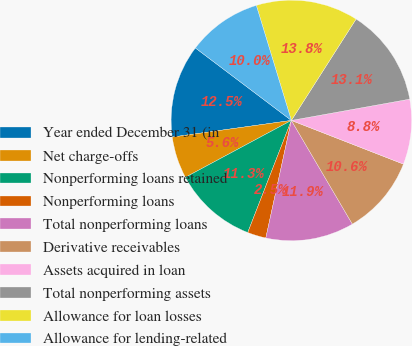Convert chart to OTSL. <chart><loc_0><loc_0><loc_500><loc_500><pie_chart><fcel>Year ended December 31 (in<fcel>Net charge-offs<fcel>Nonperforming loans retained<fcel>Nonperforming loans<fcel>Total nonperforming loans<fcel>Derivative receivables<fcel>Assets acquired in loan<fcel>Total nonperforming assets<fcel>Allowance for loan losses<fcel>Allowance for lending-related<nl><fcel>12.5%<fcel>5.63%<fcel>11.25%<fcel>2.5%<fcel>11.87%<fcel>10.62%<fcel>8.75%<fcel>13.12%<fcel>13.75%<fcel>10.0%<nl></chart> 